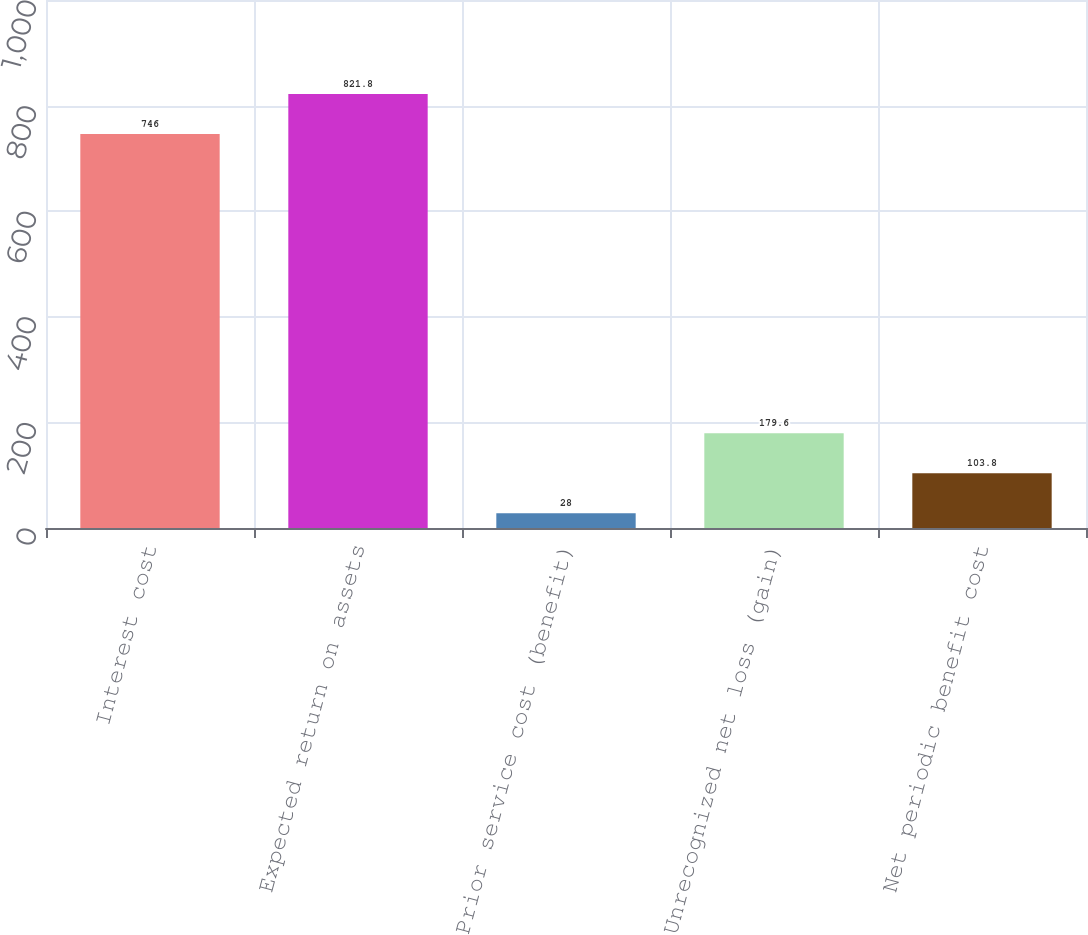Convert chart. <chart><loc_0><loc_0><loc_500><loc_500><bar_chart><fcel>Interest cost<fcel>Expected return on assets<fcel>Prior service cost (benefit)<fcel>Unrecognized net loss (gain)<fcel>Net periodic benefit cost<nl><fcel>746<fcel>821.8<fcel>28<fcel>179.6<fcel>103.8<nl></chart> 